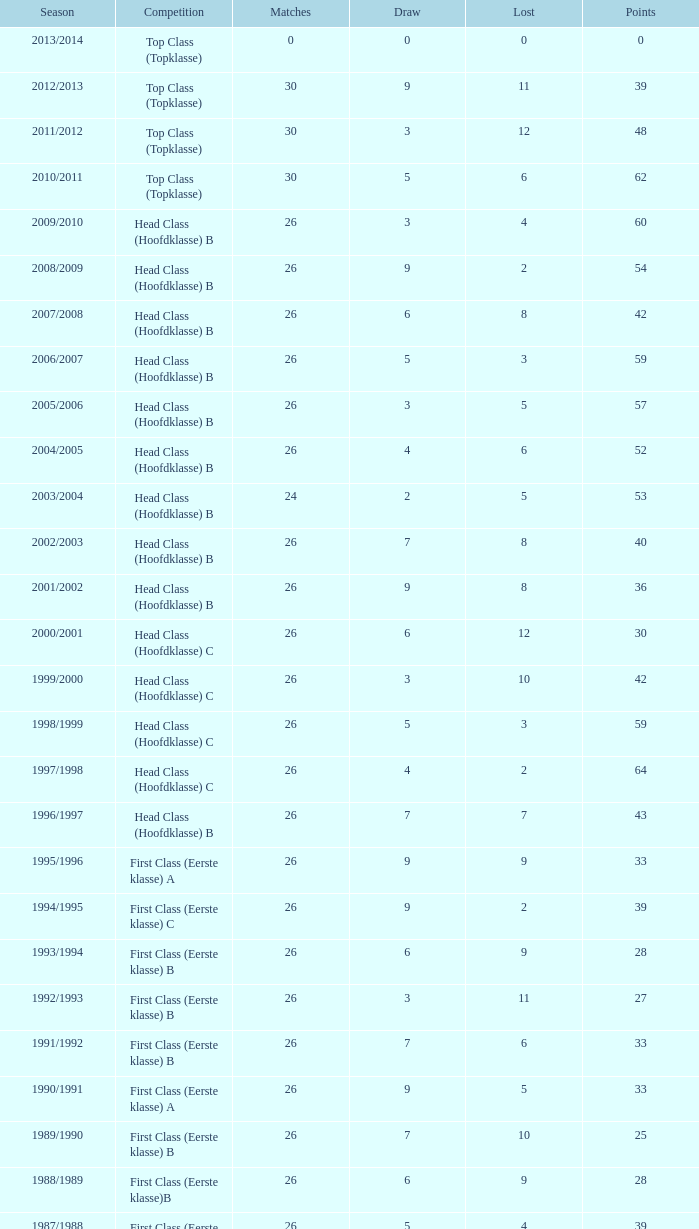What is the total of the losses when a match score exceeds 26, a points score is 62, and a draw is more than 5? None. 